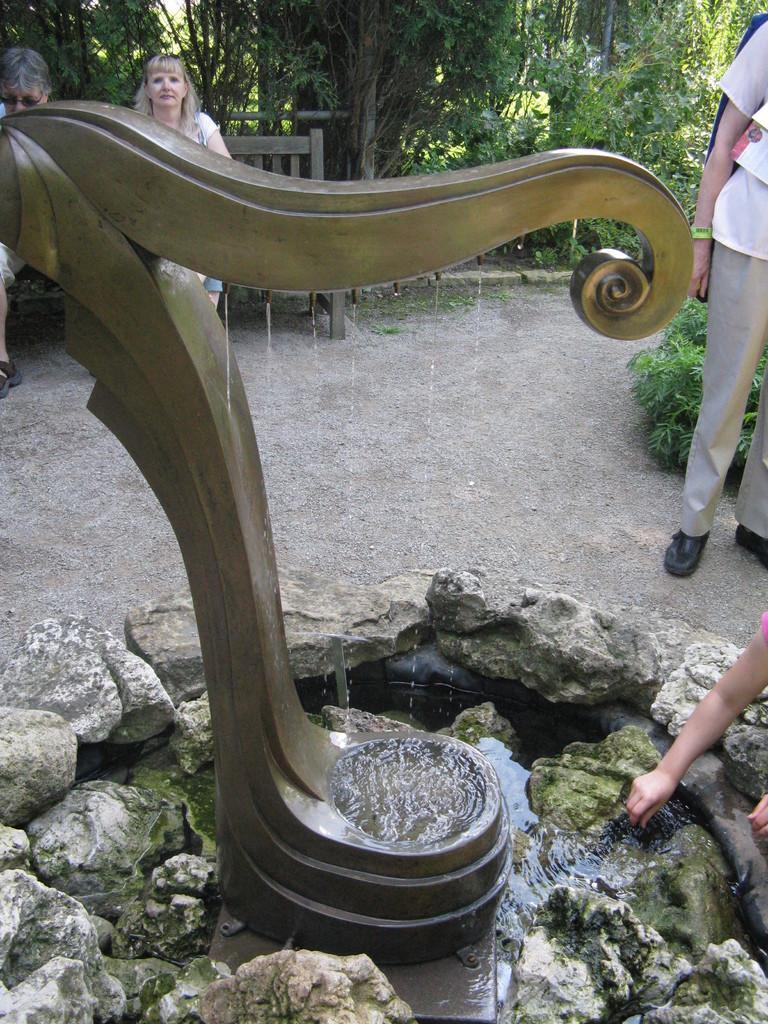Please provide a concise description of this image. There is a fountain. Around the fountain there are rocks. In the back two persons are sitting on the bench. There are trees. On the right side a person is standing. 